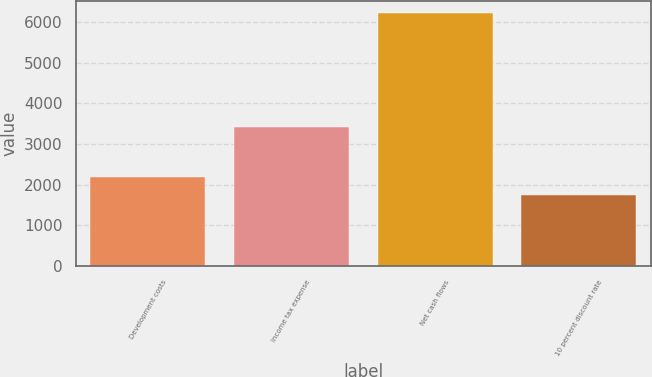Convert chart to OTSL. <chart><loc_0><loc_0><loc_500><loc_500><bar_chart><fcel>Development costs<fcel>Income tax expense<fcel>Net cash flows<fcel>10 percent discount rate<nl><fcel>2190.8<fcel>3407<fcel>6212<fcel>1744<nl></chart> 